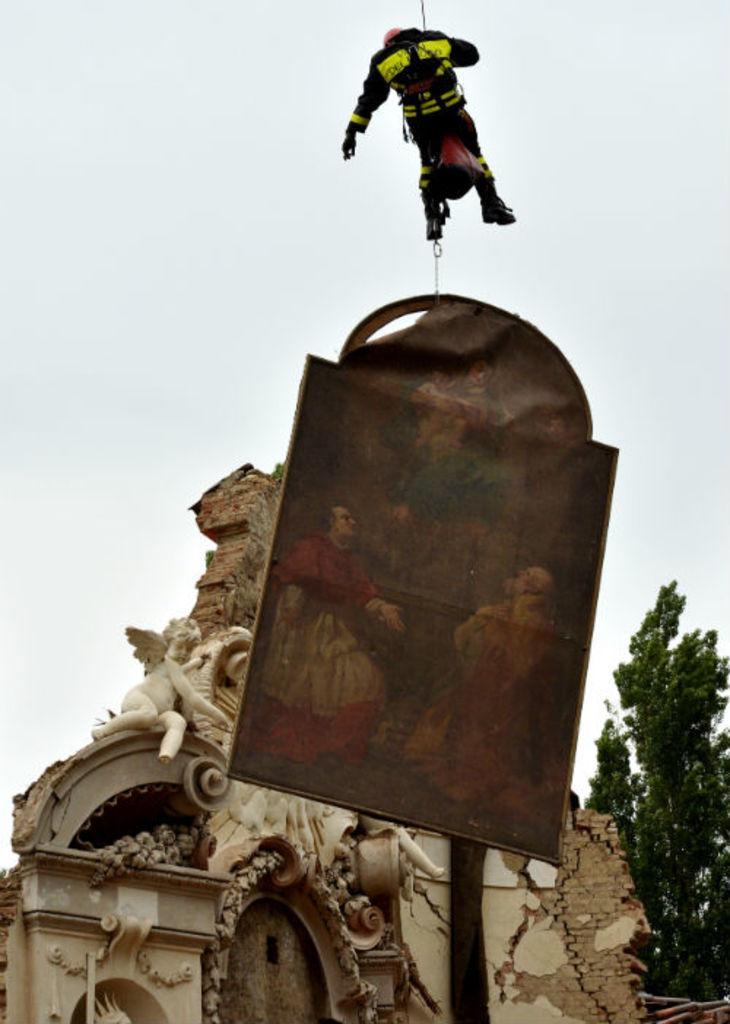Please provide a concise description of this image. In the middle of the image there is a board with images on it. Above the board there is a person hanging with the rope. Behind the board there is a wall with sculptures and arch. On the right side of the image there is a tree. In the background there is a sky. 